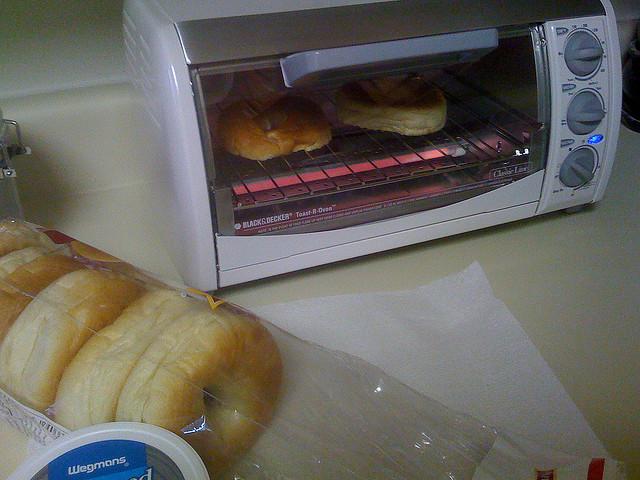How many bagels are being toasted?
Keep it brief. 1. What brand is the cream cheese?
Concise answer only. Wegmans. Are these plain bagels?
Be succinct. Yes. 